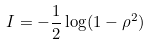Convert formula to latex. <formula><loc_0><loc_0><loc_500><loc_500>I = - \frac { 1 } { 2 } \log ( 1 - \rho ^ { 2 } )</formula> 